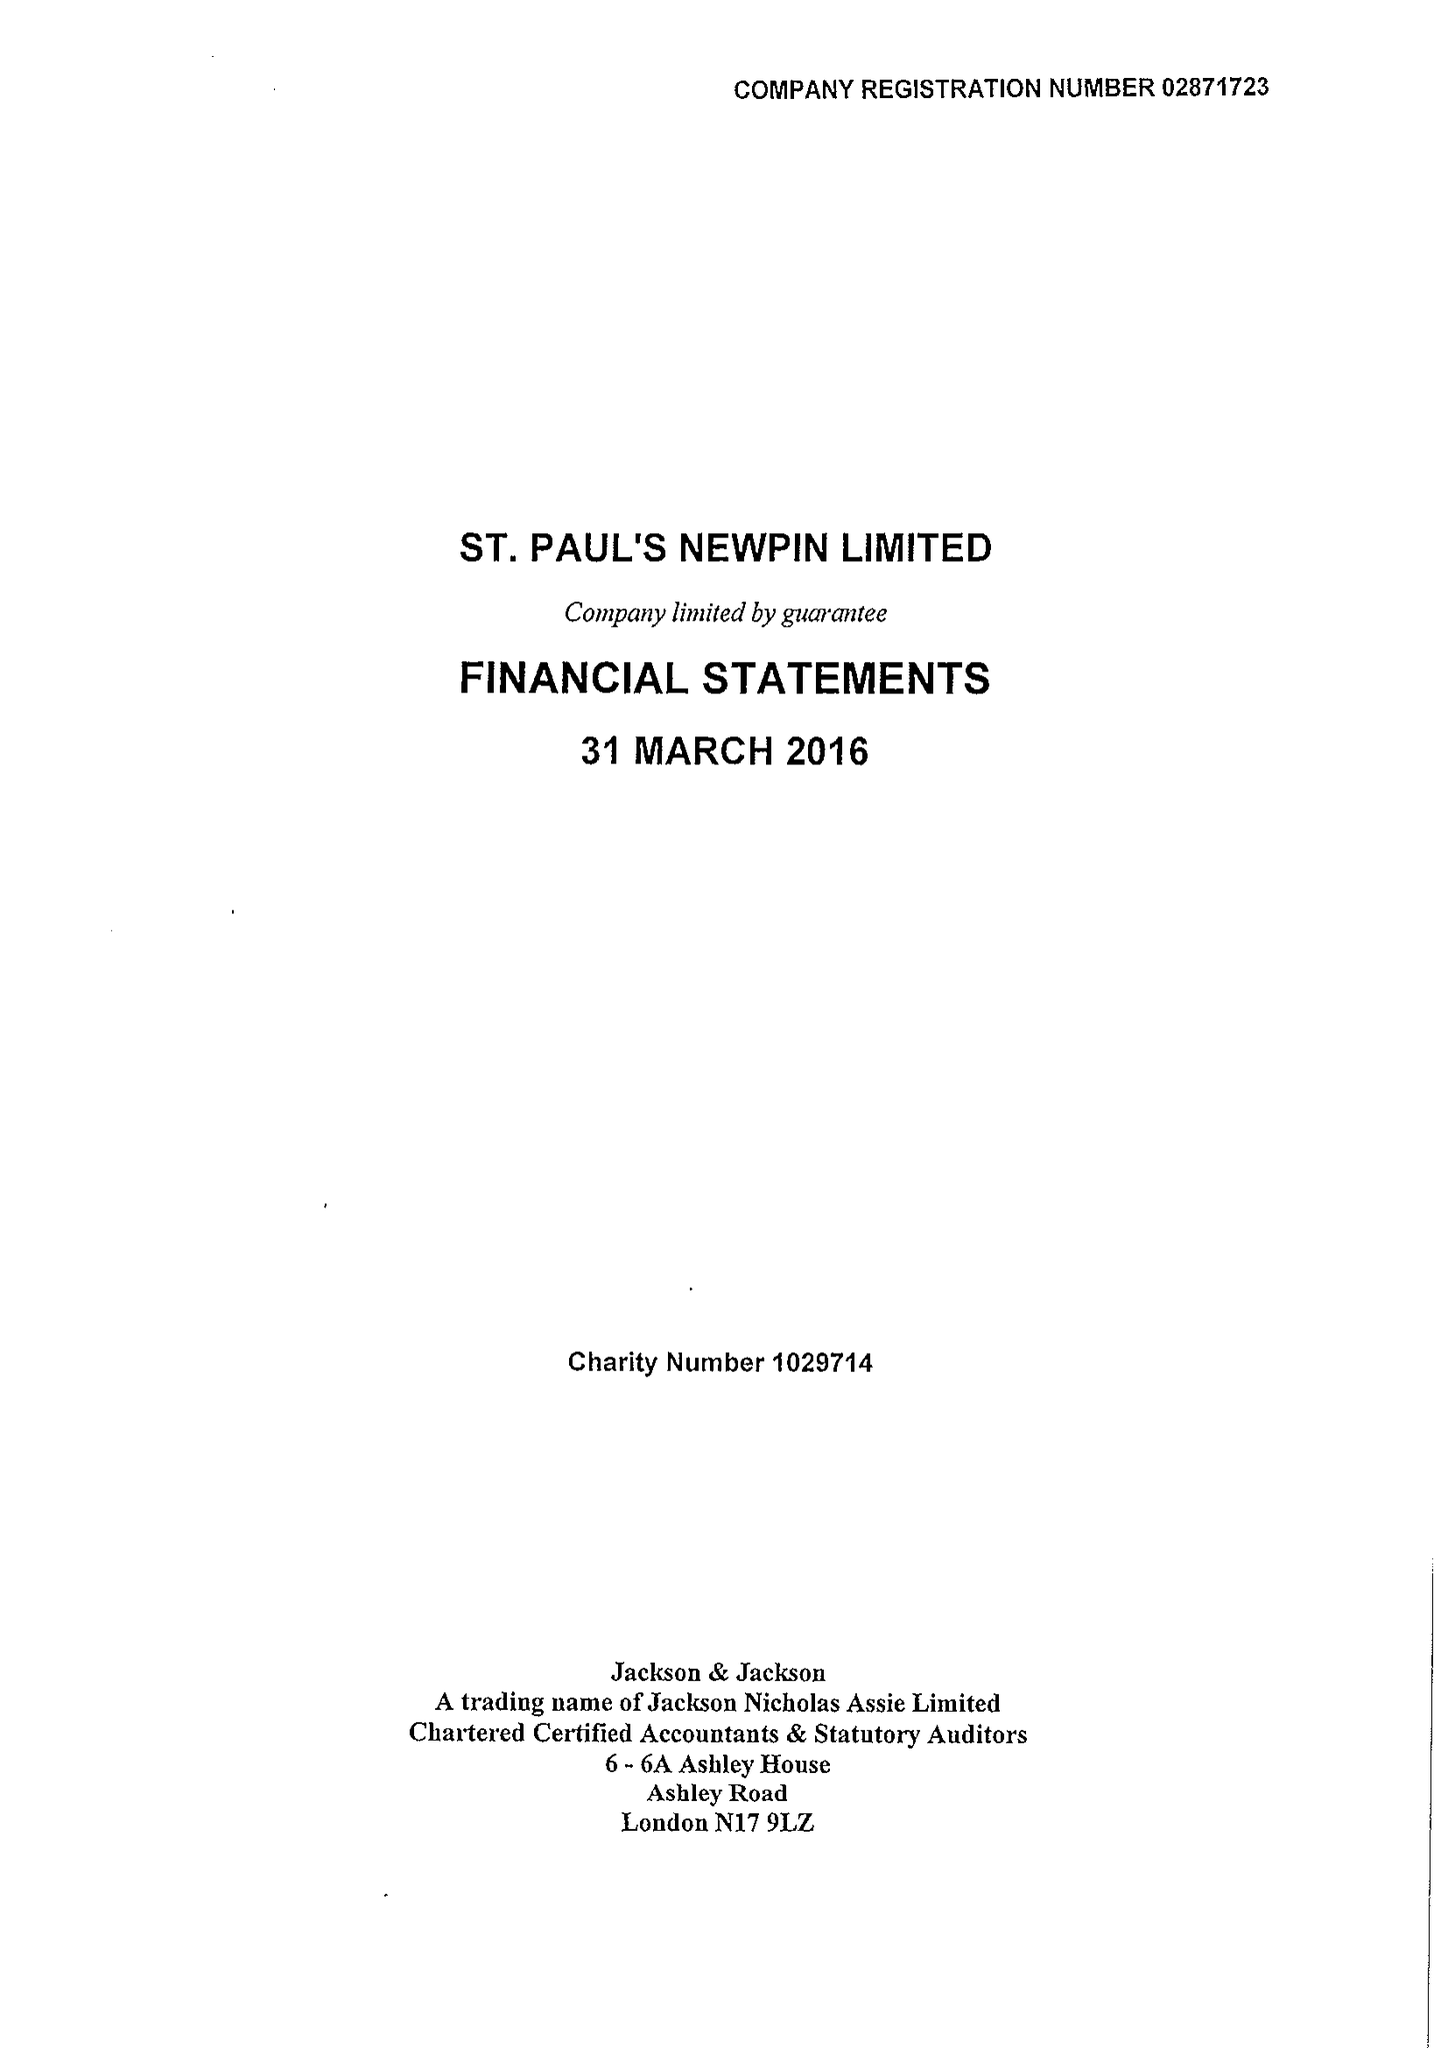What is the value for the charity_name?
Answer the question using a single word or phrase. St Paul's Newpin Ltd. 